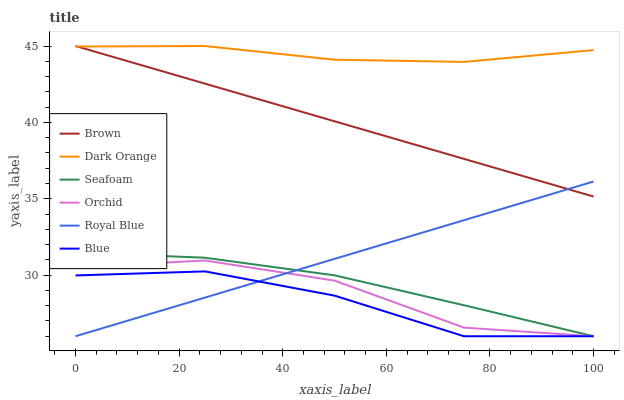Does Blue have the minimum area under the curve?
Answer yes or no. Yes. Does Dark Orange have the maximum area under the curve?
Answer yes or no. Yes. Does Brown have the minimum area under the curve?
Answer yes or no. No. Does Brown have the maximum area under the curve?
Answer yes or no. No. Is Royal Blue the smoothest?
Answer yes or no. Yes. Is Orchid the roughest?
Answer yes or no. Yes. Is Brown the smoothest?
Answer yes or no. No. Is Brown the roughest?
Answer yes or no. No. Does Blue have the lowest value?
Answer yes or no. Yes. Does Brown have the lowest value?
Answer yes or no. No. Does Brown have the highest value?
Answer yes or no. Yes. Does Dark Orange have the highest value?
Answer yes or no. No. Is Blue less than Dark Orange?
Answer yes or no. Yes. Is Brown greater than Blue?
Answer yes or no. Yes. Does Blue intersect Seafoam?
Answer yes or no. Yes. Is Blue less than Seafoam?
Answer yes or no. No. Is Blue greater than Seafoam?
Answer yes or no. No. Does Blue intersect Dark Orange?
Answer yes or no. No. 